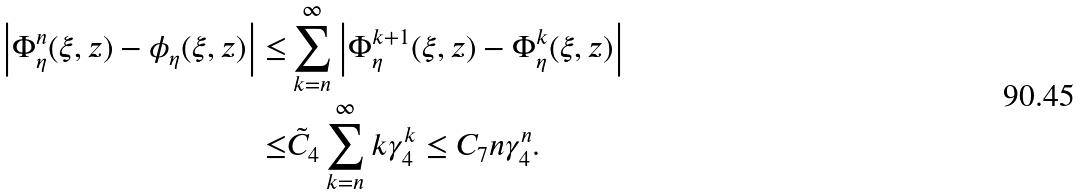<formula> <loc_0><loc_0><loc_500><loc_500>\left | \Phi _ { \eta } ^ { n } ( \xi , z ) - \phi _ { \eta } ( \xi , z ) \right | \leq & \sum _ { k = n } ^ { \infty } \left | \Phi _ { \eta } ^ { k + 1 } ( \xi , z ) - \Phi _ { \eta } ^ { k } ( \xi , z ) \right | \\ \leq & \tilde { C } _ { 4 } \sum _ { k = n } ^ { \infty } k \gamma _ { 4 } ^ { k } \leq C _ { 7 } n \gamma _ { 4 } ^ { n } .</formula> 